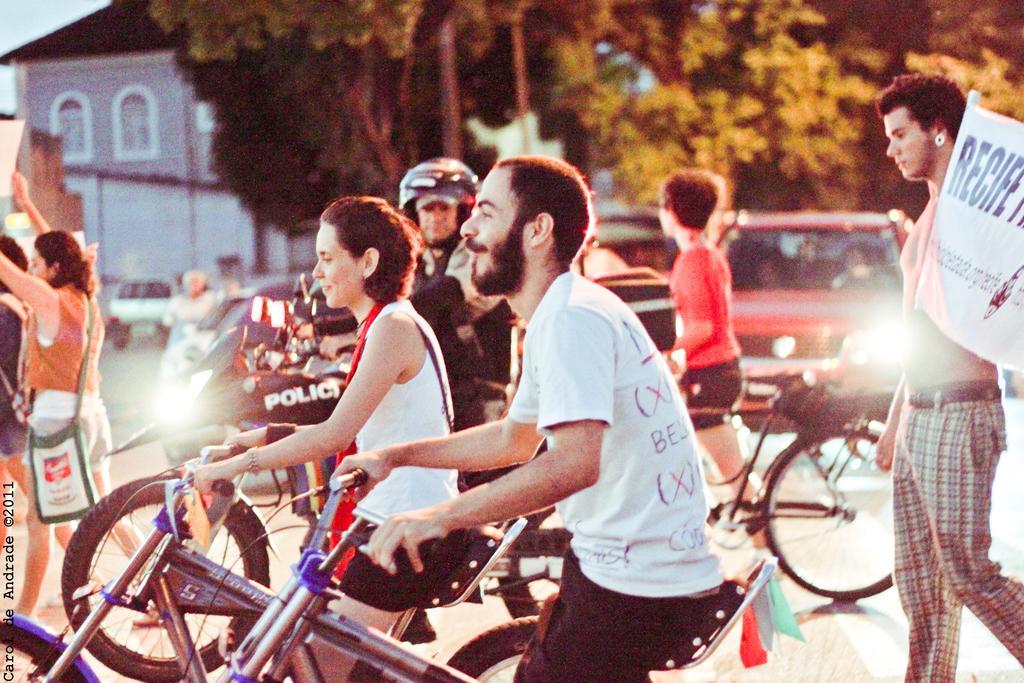How would you summarize this image in a sentence or two? In this image I can see the group of people holding the bicycles. At the back there is a person with the banner and he is walking. And there are many cars on the road. In the background there are trees and a building. 